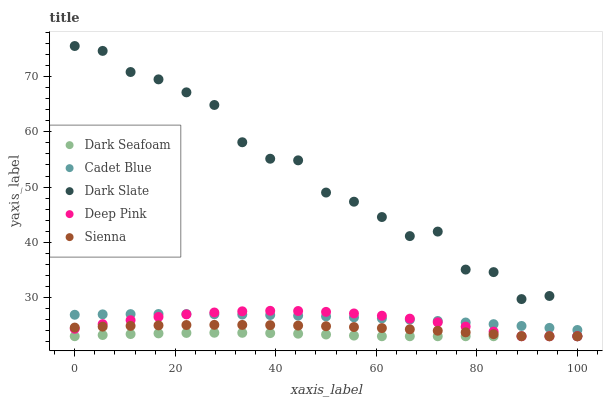Does Dark Seafoam have the minimum area under the curve?
Answer yes or no. Yes. Does Dark Slate have the maximum area under the curve?
Answer yes or no. Yes. Does Dark Slate have the minimum area under the curve?
Answer yes or no. No. Does Dark Seafoam have the maximum area under the curve?
Answer yes or no. No. Is Cadet Blue the smoothest?
Answer yes or no. Yes. Is Dark Slate the roughest?
Answer yes or no. Yes. Is Dark Seafoam the smoothest?
Answer yes or no. No. Is Dark Seafoam the roughest?
Answer yes or no. No. Does Sienna have the lowest value?
Answer yes or no. Yes. Does Cadet Blue have the lowest value?
Answer yes or no. No. Does Dark Slate have the highest value?
Answer yes or no. Yes. Does Dark Seafoam have the highest value?
Answer yes or no. No. Is Dark Seafoam less than Cadet Blue?
Answer yes or no. Yes. Is Cadet Blue greater than Sienna?
Answer yes or no. Yes. Does Cadet Blue intersect Deep Pink?
Answer yes or no. Yes. Is Cadet Blue less than Deep Pink?
Answer yes or no. No. Is Cadet Blue greater than Deep Pink?
Answer yes or no. No. Does Dark Seafoam intersect Cadet Blue?
Answer yes or no. No. 